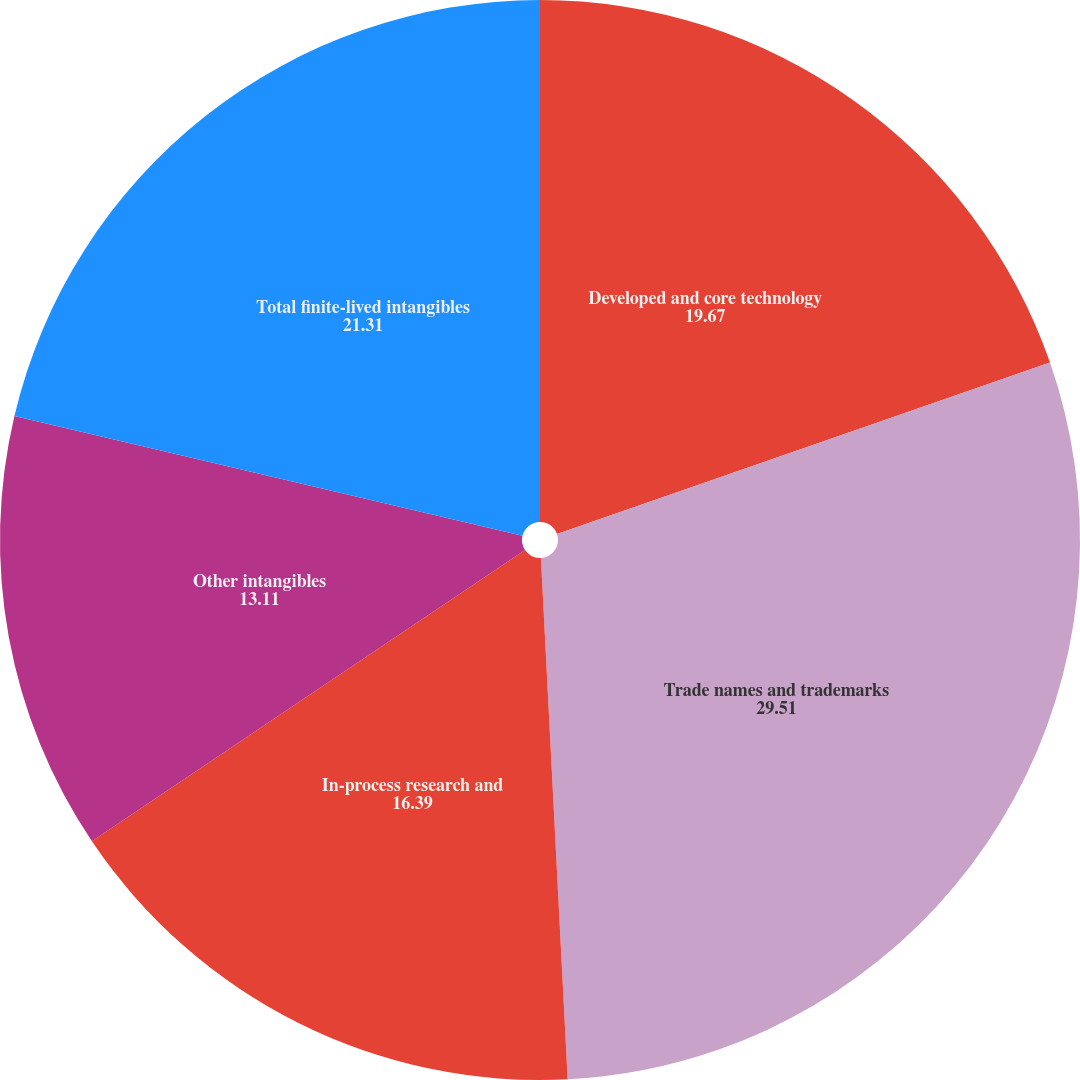<chart> <loc_0><loc_0><loc_500><loc_500><pie_chart><fcel>Developed and core technology<fcel>Trade names and trademarks<fcel>In-process research and<fcel>Other intangibles<fcel>Total finite-lived intangibles<nl><fcel>19.67%<fcel>29.51%<fcel>16.39%<fcel>13.11%<fcel>21.31%<nl></chart> 